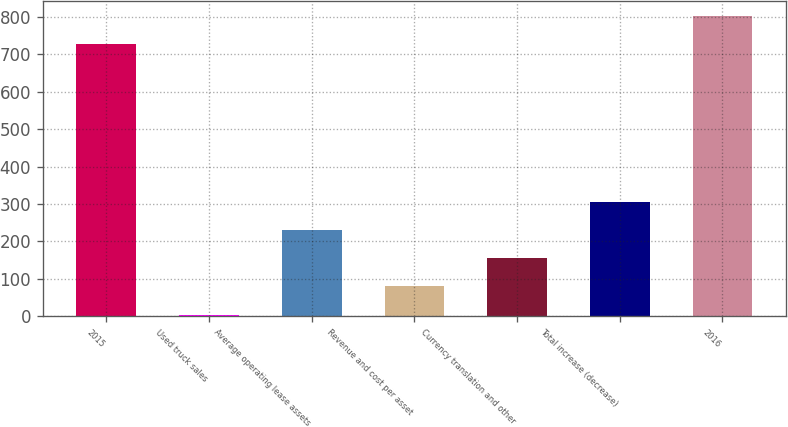<chart> <loc_0><loc_0><loc_500><loc_500><bar_chart><fcel>2015<fcel>Used truck sales<fcel>Average operating lease assets<fcel>Revenue and cost per asset<fcel>Currency translation and other<fcel>Total increase (decrease)<fcel>2016<nl><fcel>728.5<fcel>3.2<fcel>230.39<fcel>78.93<fcel>154.66<fcel>306.12<fcel>804.23<nl></chart> 